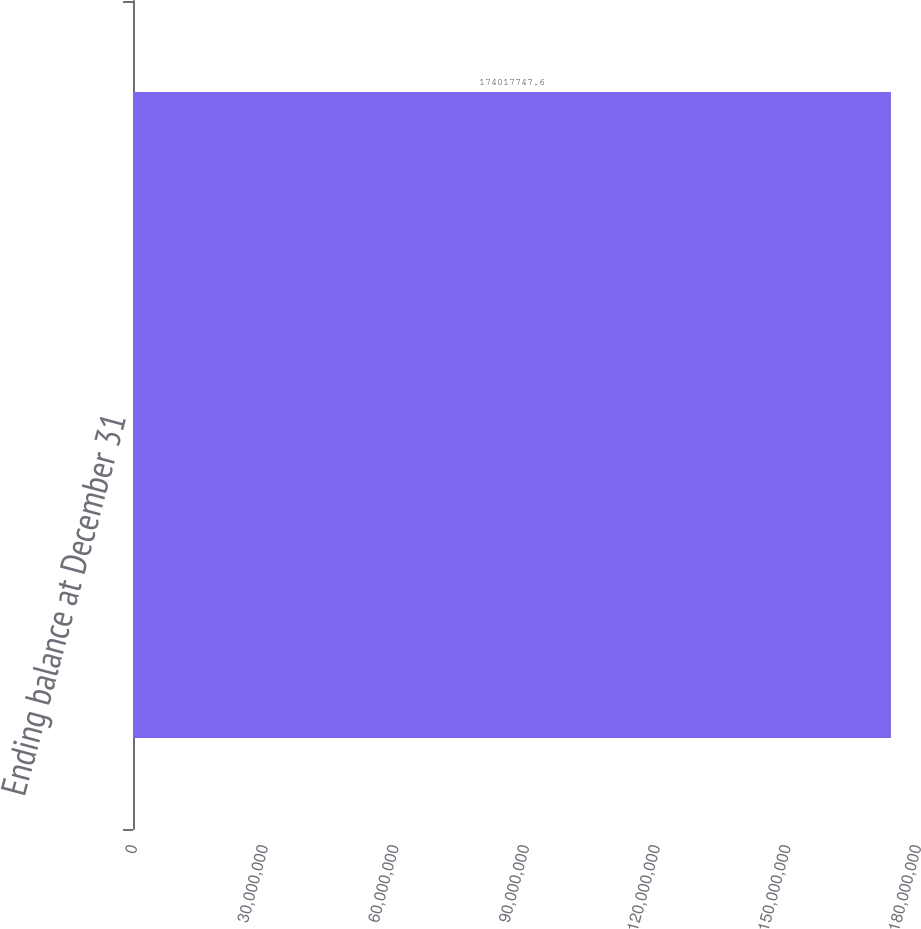<chart> <loc_0><loc_0><loc_500><loc_500><bar_chart><fcel>Ending balance at December 31<nl><fcel>1.74018e+08<nl></chart> 